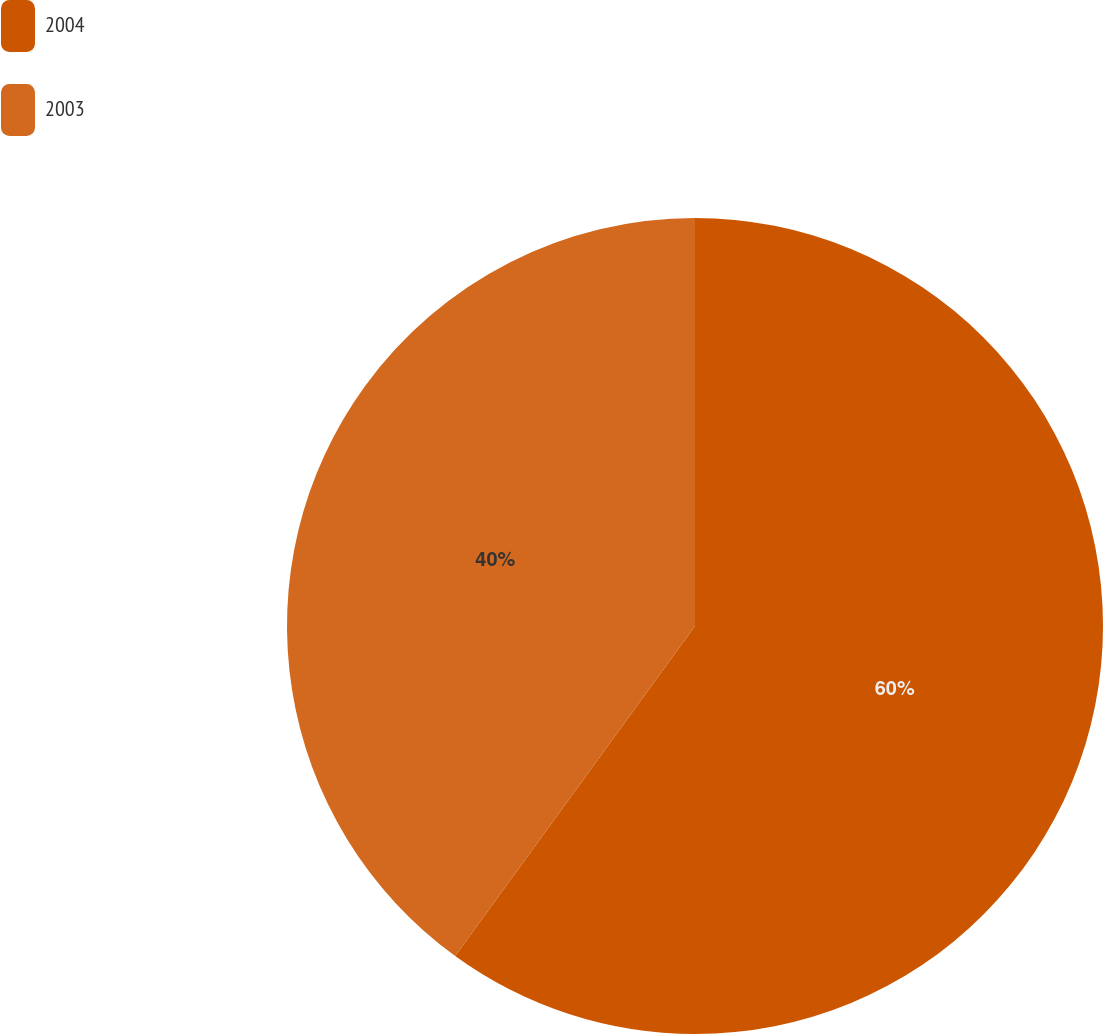Convert chart. <chart><loc_0><loc_0><loc_500><loc_500><pie_chart><fcel>2004<fcel>2003<nl><fcel>60.0%<fcel>40.0%<nl></chart> 